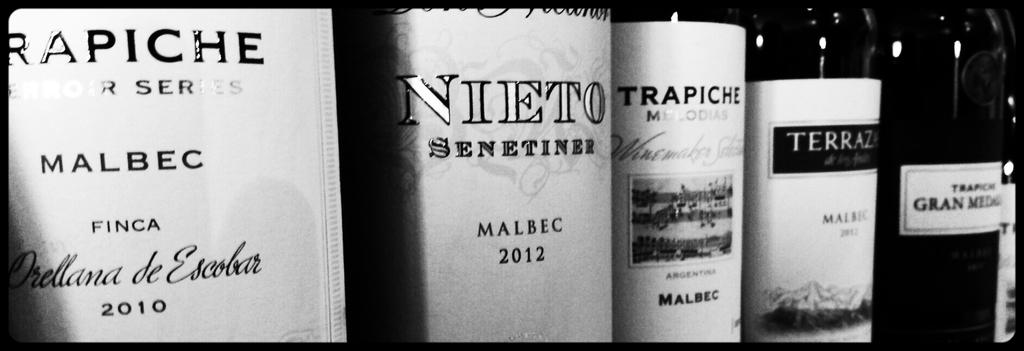<image>
Summarize the visual content of the image. Bottles of alcohol with labels that say MALBEC on it. 